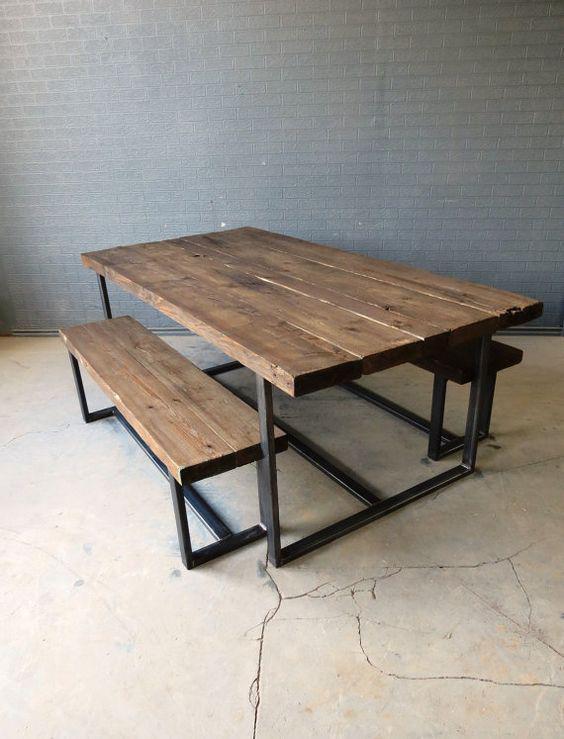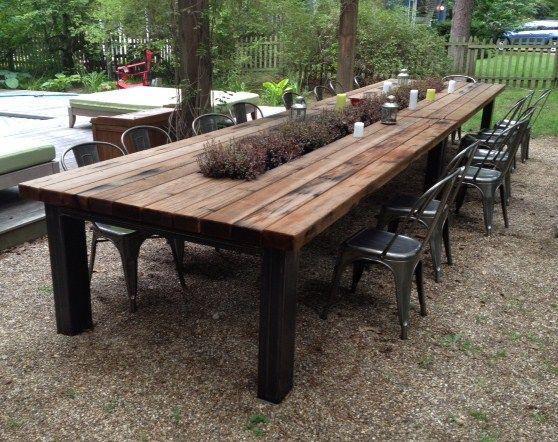The first image is the image on the left, the second image is the image on the right. Examine the images to the left and right. Is the description "In one image, a rectangular wooden table has two long bench seats, one on each side." accurate? Answer yes or no. Yes. The first image is the image on the left, the second image is the image on the right. Assess this claim about the two images: "There is a concrete floor visible.". Correct or not? Answer yes or no. Yes. 